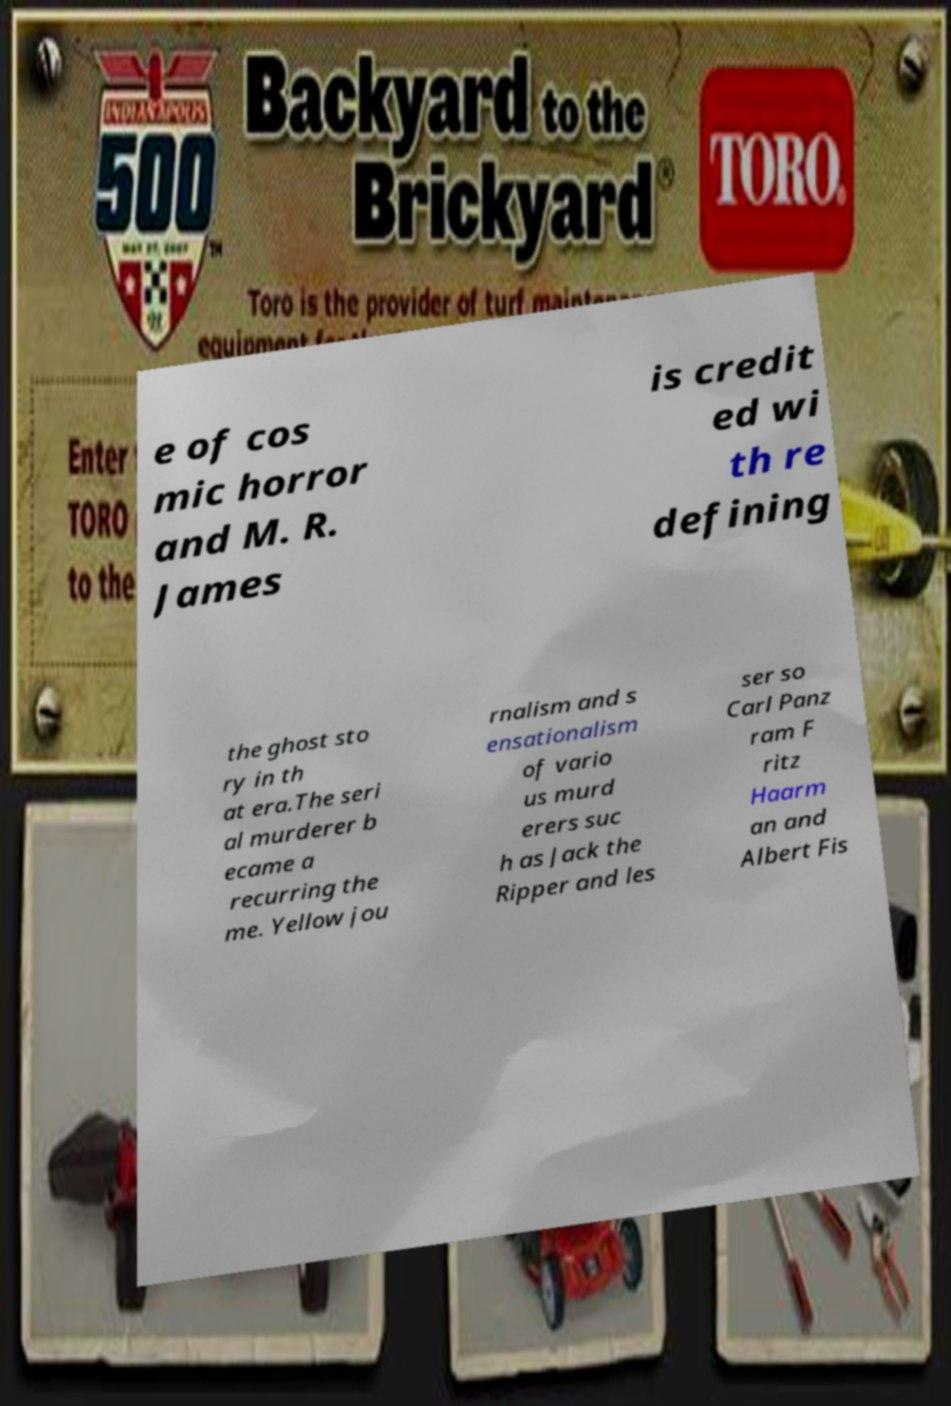Could you assist in decoding the text presented in this image and type it out clearly? e of cos mic horror and M. R. James is credit ed wi th re defining the ghost sto ry in th at era.The seri al murderer b ecame a recurring the me. Yellow jou rnalism and s ensationalism of vario us murd erers suc h as Jack the Ripper and les ser so Carl Panz ram F ritz Haarm an and Albert Fis 